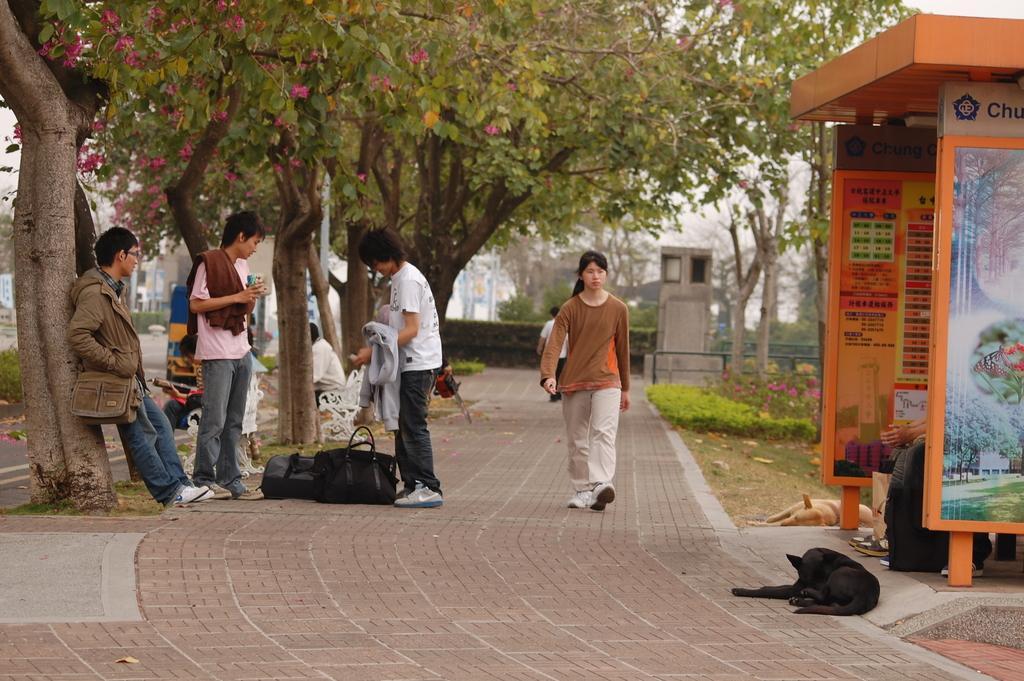In one or two sentences, can you explain what this image depicts? In this picture I can see few trees and a man seated on the bench and few are standing and I can see couple of bags on the floor and a man wore a bag and we see couple of them walking on the sidewalk and I can see a woman seated in the shelter on the side walk and couple of dogs sleeping on the ground and i can see few plants with flowers. 